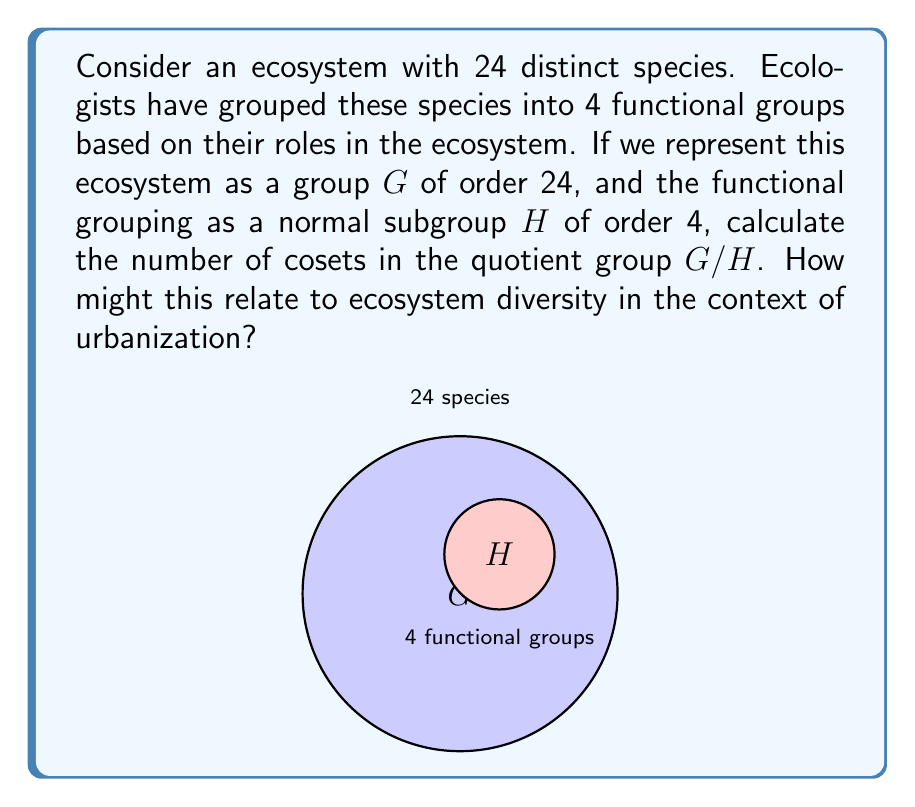Show me your answer to this math problem. Let's approach this step-by-step:

1) First, recall the Lagrange's Theorem: For a finite group $G$ and a subgroup $H$ of $G$, the order of $H$ divides the order of $G$. The number of cosets of $H$ in $G$ is equal to the index of $H$ in $G$, denoted as $[G:H]$.

2) The index $[G:H]$ is calculated as:

   $$[G:H] = \frac{|G|}{|H|}$$

   where $|G|$ is the order of $G$ and $|H|$ is the order of $H$.

3) In this case:
   $|G| = 24$ (total number of species)
   $|H| = 4$ (number of functional groups)

4) Substituting these values:

   $$[G:H] = \frac{24}{4} = 6$$

5) Therefore, there are 6 cosets in the quotient group $G/H$.

6) In the context of urbanization and ecosystem diversity:
   - Each coset could represent a distinct ecological niche or habitat type within the urban ecosystem.
   - The number of cosets (6) indicates the level of diversity in ecosystem functions that persist despite grouping species into functional groups.
   - As urbanization progresses, some of these cosets might be lost, representing a decline in ecosystem diversity and potentially affecting natural resource management.
Answer: 6 cosets 